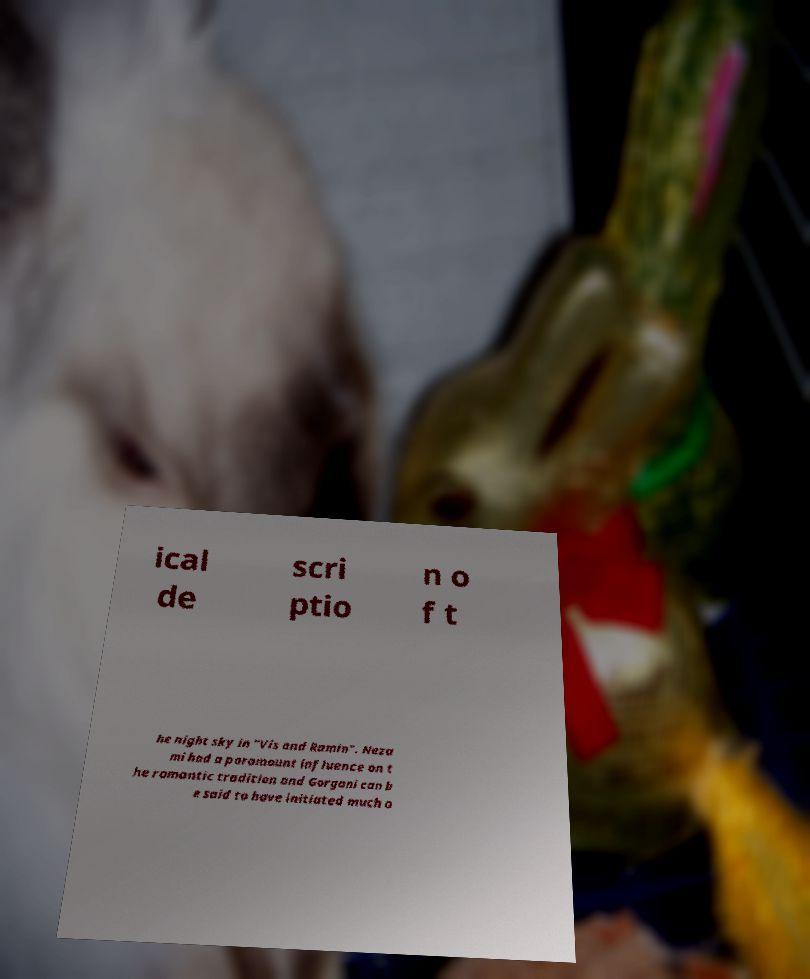Please identify and transcribe the text found in this image. ical de scri ptio n o f t he night sky in "Vis and Ramin". Neza mi had a paramount influence on t he romantic tradition and Gorgani can b e said to have initiated much o 